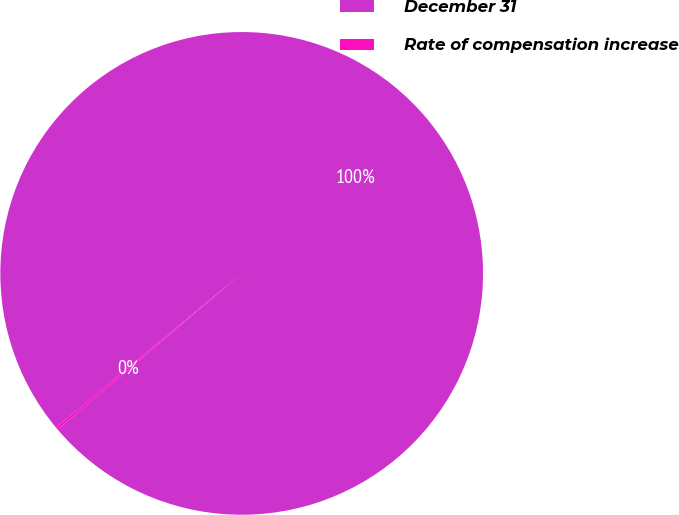<chart> <loc_0><loc_0><loc_500><loc_500><pie_chart><fcel>December 31<fcel>Rate of compensation increase<nl><fcel>99.83%<fcel>0.17%<nl></chart> 